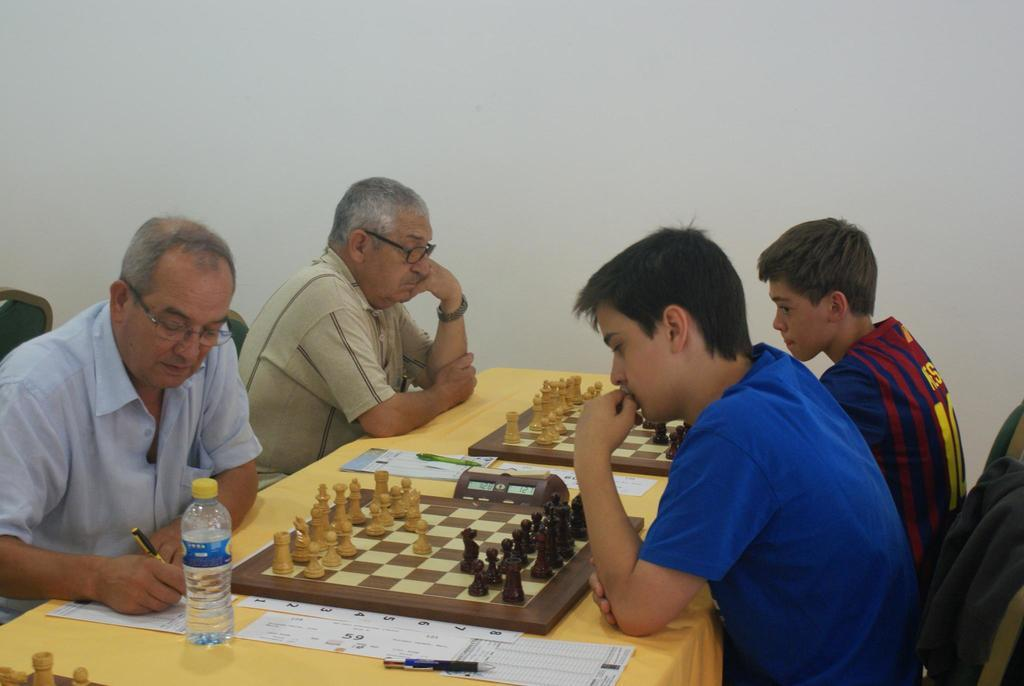How many men are present in the image? There are 4 men in the image. What are the men doing in the image? The men are playing a chess game. What objects are on the table in the image? There is a water bottle, pens, paper, a chess board, and coins on the table. What is the background of the image? There is a wall in the background of the image. How does the chess game connect to the oil industry in the image? There is no mention of the oil industry in the image, and the chess game is not connected to it. 